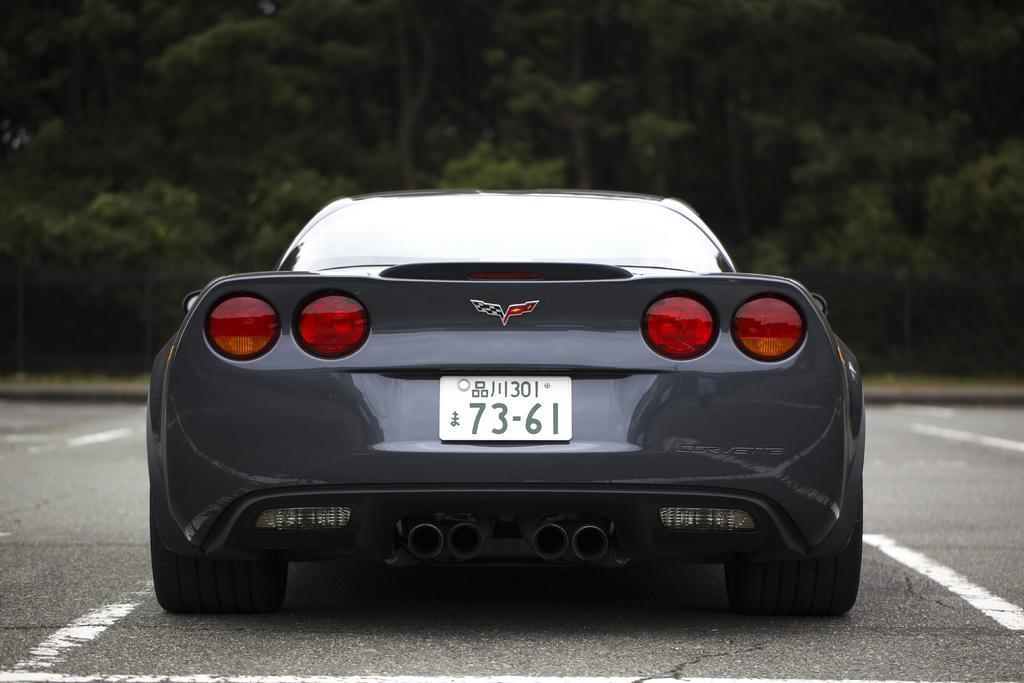<image>
Describe the image concisely. The back of gray sports car with the licence plate 73-61 is parked in a car park. 